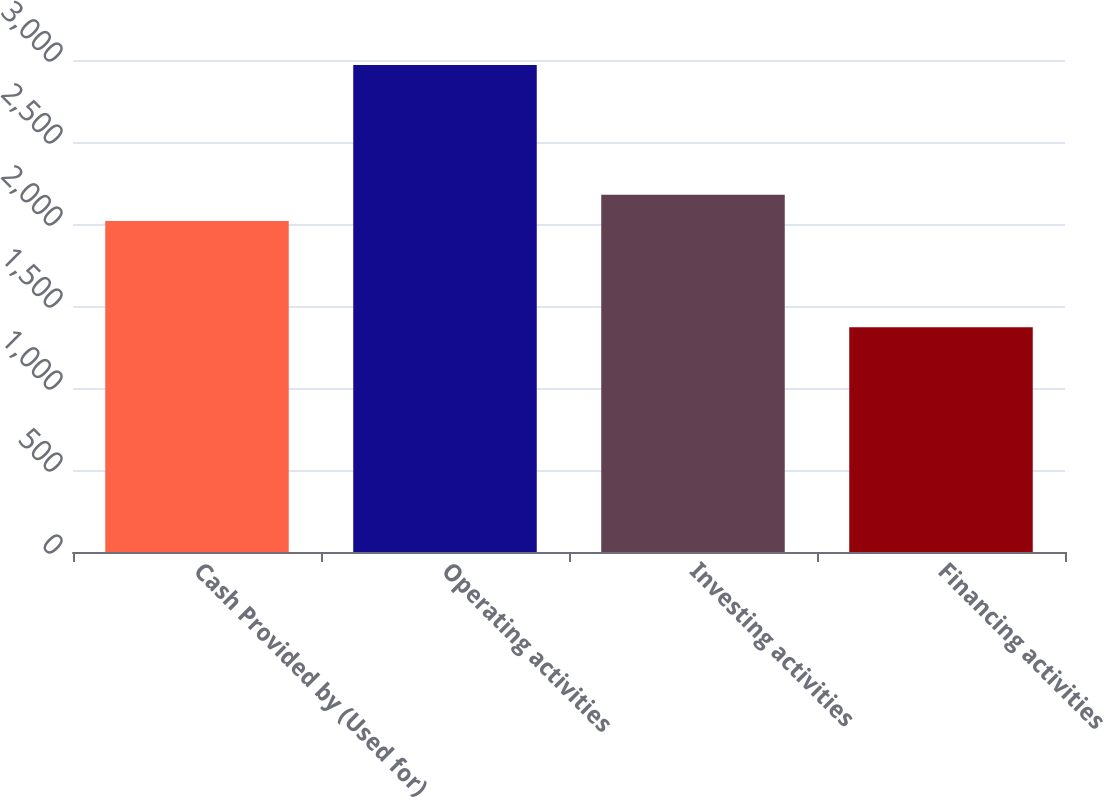<chart> <loc_0><loc_0><loc_500><loc_500><bar_chart><fcel>Cash Provided by (Used for)<fcel>Operating activities<fcel>Investing activities<fcel>Financing activities<nl><fcel>2019<fcel>2969.9<fcel>2178.94<fcel>1370.5<nl></chart> 